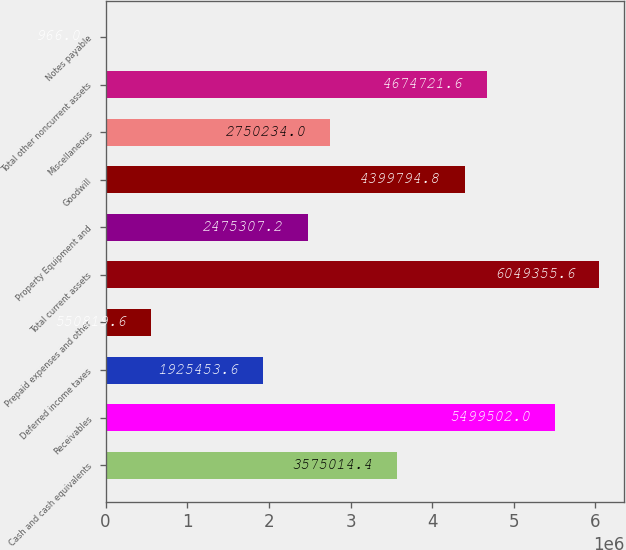Convert chart to OTSL. <chart><loc_0><loc_0><loc_500><loc_500><bar_chart><fcel>Cash and cash equivalents<fcel>Receivables<fcel>Deferred income taxes<fcel>Prepaid expenses and other<fcel>Total current assets<fcel>Property Equipment and<fcel>Goodwill<fcel>Miscellaneous<fcel>Total other noncurrent assets<fcel>Notes payable<nl><fcel>3.57501e+06<fcel>5.4995e+06<fcel>1.92545e+06<fcel>550820<fcel>6.04936e+06<fcel>2.47531e+06<fcel>4.39979e+06<fcel>2.75023e+06<fcel>4.67472e+06<fcel>966<nl></chart> 